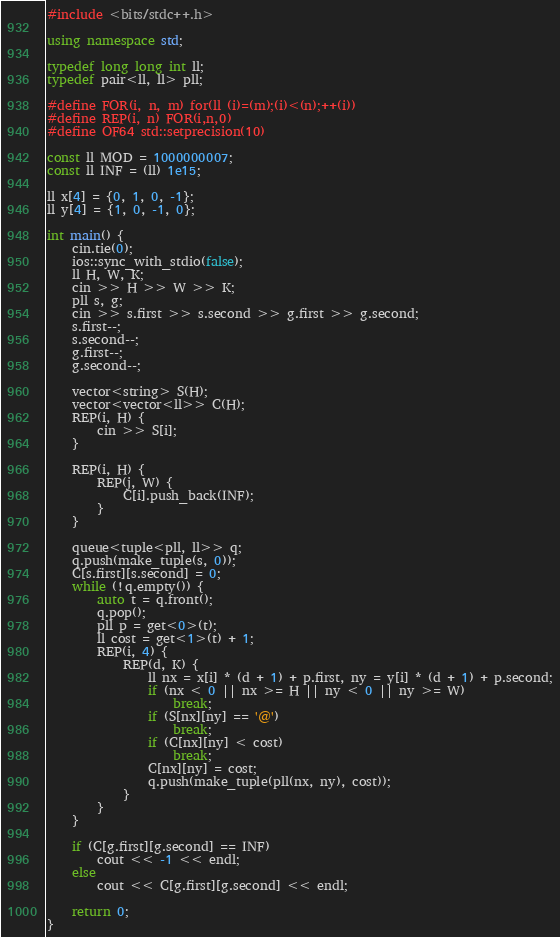<code> <loc_0><loc_0><loc_500><loc_500><_C++_>#include <bits/stdc++.h>

using namespace std;

typedef long long int ll;
typedef pair<ll, ll> pll;

#define FOR(i, n, m) for(ll (i)=(m);(i)<(n);++(i))
#define REP(i, n) FOR(i,n,0)
#define OF64 std::setprecision(10)

const ll MOD = 1000000007;
const ll INF = (ll) 1e15;

ll x[4] = {0, 1, 0, -1};
ll y[4] = {1, 0, -1, 0};

int main() {
    cin.tie(0);
    ios::sync_with_stdio(false);
    ll H, W, K;
    cin >> H >> W >> K;
    pll s, g;
    cin >> s.first >> s.second >> g.first >> g.second;
    s.first--;
    s.second--;
    g.first--;
    g.second--;

    vector<string> S(H);
    vector<vector<ll>> C(H);
    REP(i, H) {
        cin >> S[i];
    }

    REP(i, H) {
        REP(j, W) {
            C[i].push_back(INF);
        }
    }

    queue<tuple<pll, ll>> q;
    q.push(make_tuple(s, 0));
    C[s.first][s.second] = 0;
    while (!q.empty()) {
        auto t = q.front();
        q.pop();
        pll p = get<0>(t);
        ll cost = get<1>(t) + 1;
        REP(i, 4) {
            REP(d, K) {
                ll nx = x[i] * (d + 1) + p.first, ny = y[i] * (d + 1) + p.second;
                if (nx < 0 || nx >= H || ny < 0 || ny >= W)
                    break;
                if (S[nx][ny] == '@')
                    break;
                if (C[nx][ny] < cost)
                    break;
                C[nx][ny] = cost;
                q.push(make_tuple(pll(nx, ny), cost));
            }
        }
    }

    if (C[g.first][g.second] == INF)
        cout << -1 << endl;
    else
        cout << C[g.first][g.second] << endl;

    return 0;
}</code> 